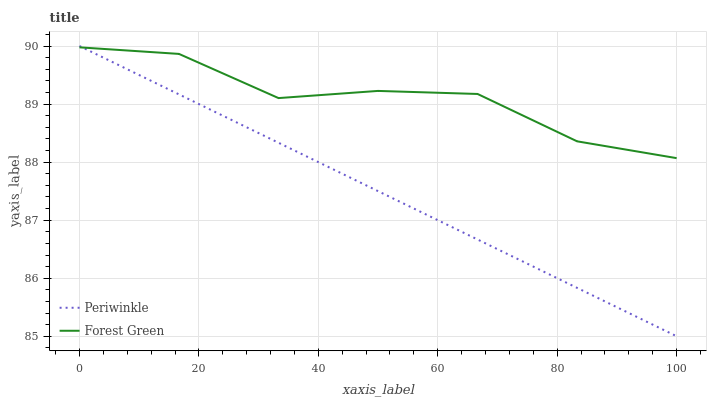Does Periwinkle have the maximum area under the curve?
Answer yes or no. No. Is Periwinkle the roughest?
Answer yes or no. No. 